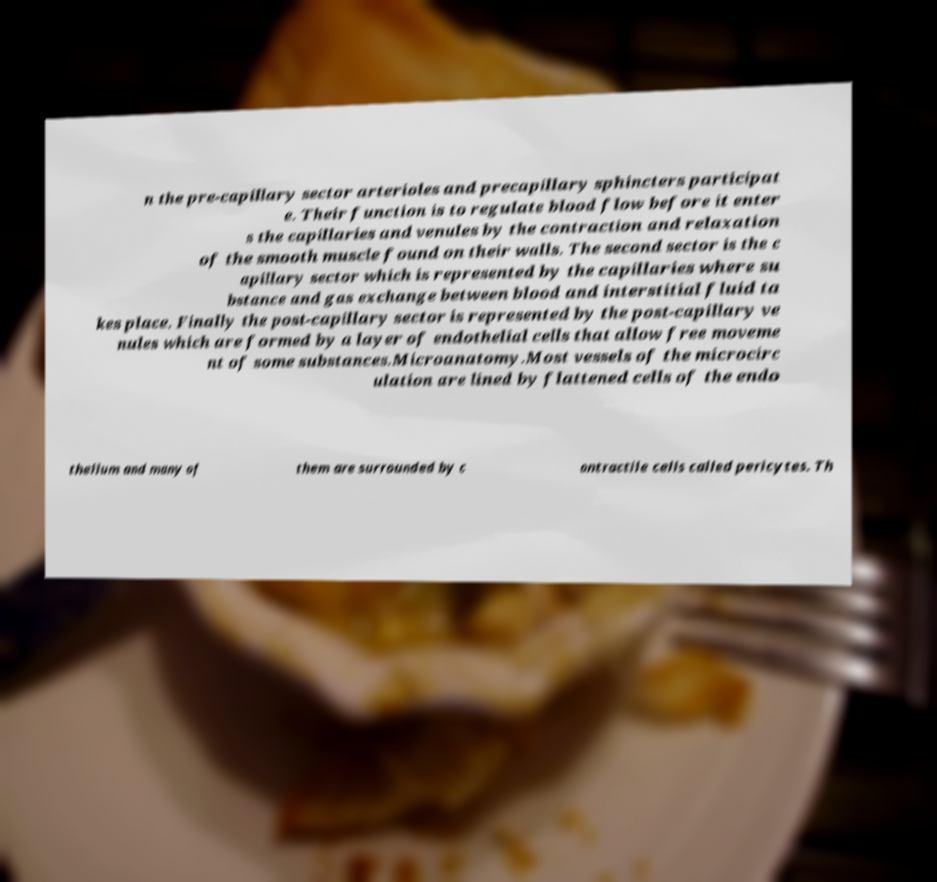Could you extract and type out the text from this image? n the pre-capillary sector arterioles and precapillary sphincters participat e. Their function is to regulate blood flow before it enter s the capillaries and venules by the contraction and relaxation of the smooth muscle found on their walls. The second sector is the c apillary sector which is represented by the capillaries where su bstance and gas exchange between blood and interstitial fluid ta kes place. Finally the post-capillary sector is represented by the post-capillary ve nules which are formed by a layer of endothelial cells that allow free moveme nt of some substances.Microanatomy.Most vessels of the microcirc ulation are lined by flattened cells of the endo thelium and many of them are surrounded by c ontractile cells called pericytes. Th 